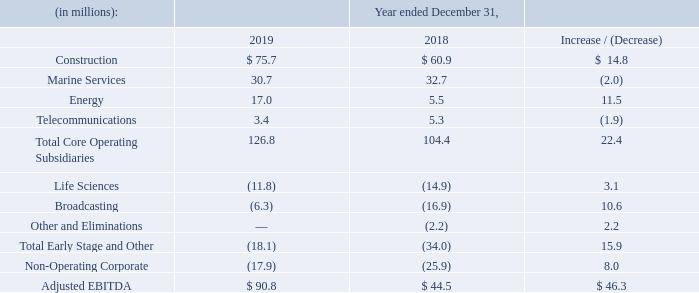Construction: Net income from our Construction segment for the year ended December 31, 2019 decreased $3.0 million to $24.7 million from $27.7 million for the year ended December 31, 2018. Adjusted EBITDA from our Construction segment for the year ended December 31, 2019 increased $14.8 million to $75.7 million from $60.9 million for the year ended December 31, 2018. The increase in Adjusted EBITDA was driven by the acquisition of GrayWolf.
Marine Services: Net income (loss) from our Marine Services segment for the year ended December 31, 2019 decreased $2.9 million to a loss of $2.6 million from income of $0.3 million for the year ended December 31, 2018. Adjusted EBITDA from our Marine Services segment for the year ended December 31, 2019 decreased $2.0 million to $30.7 million from $32.7 million for the year ended December 31, 2018.
The decrease in Adjusted EBITDA was driven by a decline in income from equity method investees, due to HMN driven by lower revenues on large turnkey projects underway than in the comparable period, and losses at SBSS from a loss contingency related to ongoing legal disputes and lower vessel utilization.
Largely offsetting these losses was higher gross profit as a result of improved profitability from telecom maintenance zones and project work in the offshore power and offshore renewables end markets, as well as the benefit of improved vessel utilization. Additionally, the comparable period was impacted by higher than expected costs on a certain offshore power construction project that were not repeated in the current period.
Energy: Net income (loss) from our Energy segment for the year ended December 31, 2019 increased by $5.1 million to income of $4.2 million from a loss of $0.9 million for the year ended December 31, 2018. Adjusted EBITDA from our Energy segment for the year ended December 31, 2019 increased $11.5 million to $17.0 million from $5.5 million for the year ended December 31, 2018.
The increase in Adjusted EBITDA was primarily driven by the AFTC recognized in the fourth quarter of 2019 attributable to 2018 and 2019 and higher volume-related revenues from the recent acquisition of the ampCNG stations and growth in CNG sales volumes. The increase was also driven by Partially offsetting these increases were higher selling, general and administrative expenses as a result of the acquisition of the ampCNG stations.
Telecommunications: Net income (loss) from our Telecommunications segment for the year ended December 31, 2019 decreased by $6.0 million to a loss of $1.4 million from income of $4.6 million for the year ended December 31, 2018. Adjusted EBITDA from our Telecommunications segment for the year ended December 31, 2019 decreased $1.9 million to $3.4 million from $5.3 million for the year ended December 31, 2018.
The decrease in Adjusted EBITDA was primarily due to both a decline in revenue and the contracting of call termination margin as a result of the continued decline in the international long distance market, partially offset by a decrease in compensation expense due to headcount decreases and reductions in bad debt expense.
Life Sciences: Net income (loss) from our Life Sciences segment for the year ended December 31, 2019 decreased $65.4 million to a loss of $0.2 million from income of $65.2 million for the year ended December 31, 2018. Adjusted EBITDA loss from our Life Sciences segment for the year ended December 31, 2019 decreased $3.1 million to $11.8 million from $14.9 million for the year ended December 31, 2018.
The decrease in Adjusted EBITDA loss was primarily driven by comparably fewer expenses at the Pansend holding company, which incurred additional compensation expense in the prior period related to the performance of the segment. The decrease was also due to a reduction in costs associated BeneVir, which was sold in the second quarter of 2018.
Broadcasting: Net loss from our Broadcasting segment for the year ended December 31, 2019 decreased $16.0 million to $18.5 million from $34.5 million for the year ended December 31, 2018. Adjusted EBITDA loss from our Broadcasting segment for the year ended December 31, 2019 decreased $10.6 million to $6.3 million from $16.9 million for the year ended December 31, 2018.
The decrease in Adjusted EBITDA loss was primarily driven by the reduction in costs as the segment exited certain local markets which were unprofitable at Network, partially offset by higher overhead expenses associated with the growth of the Broadcast stations subsequent to the prior year.
Non-operating Corporate: Net loss from our Non-operating Corporate segment for the year ended December 31, 2019 increased $5.7 million to $87.6 million from $81.9 million for the year ended December 31, 2018. Adjusted EBITDA loss from our Non-operating Corporate segment for the year ended December 31, 2019 decreased $8.0 million to $17.9 million from $25.9 million for the year ended December 31, 2018.
The decrease in Adjusted EBITDA loss was primarily attributable to reductions in bonus expense and other general and administrative expenses as previously described.
What was the net income for the year ended December 31, 2019? $24.7 million. What caused the decrease in adjusted EBITDA? The decrease in adjusted ebitda was driven by a decline in income from equity method investees, due to hmn driven by lower revenues on large turnkey projects underway than in the comparable period, and losses at sbss from a loss contingency related to ongoing legal disputes and lower vessel utilization. What was the net income from Marine Services in 2019? $2.6 million. What was the percentage increase / (decrease) in the construction from 2018 to 2019?
Answer scale should be: percent. 75.7 / 60.9 - 1
Answer: 24.3. What was the average Marine Services?
Answer scale should be: million. (30.7 + 32.7) / 2
Answer: 31.7. What is the percentage increase / (decrease) in Energy from 2018 to 2019?
Answer scale should be: percent. 17.0 / 5.5 - 1
Answer: 209.09. 